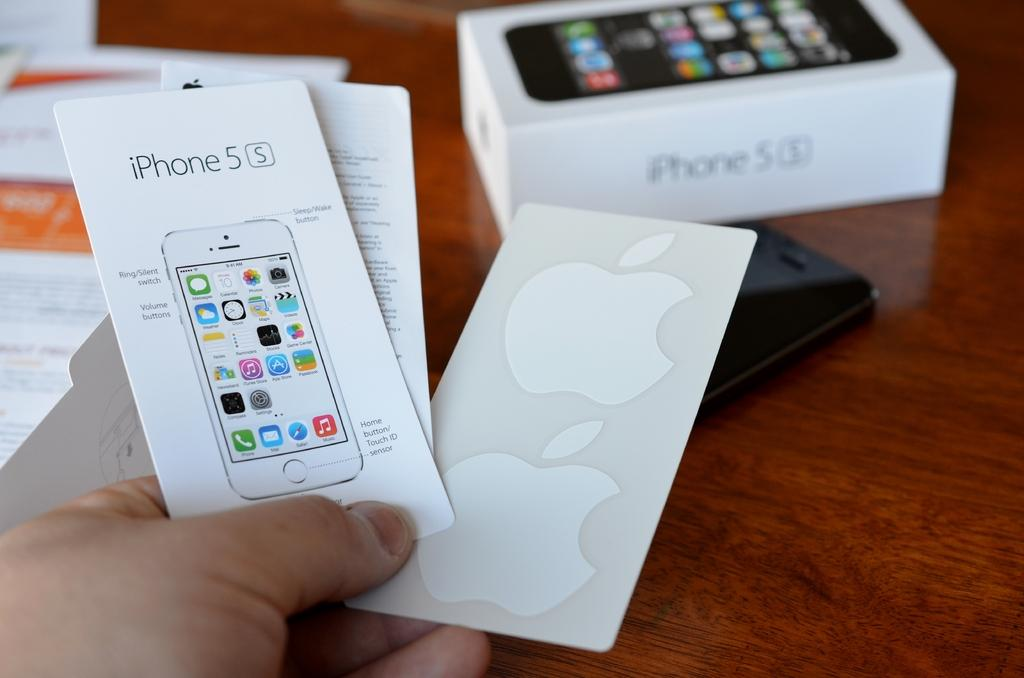<image>
Relay a brief, clear account of the picture shown. Someone is holding on to iPhone 5 information sheets. 